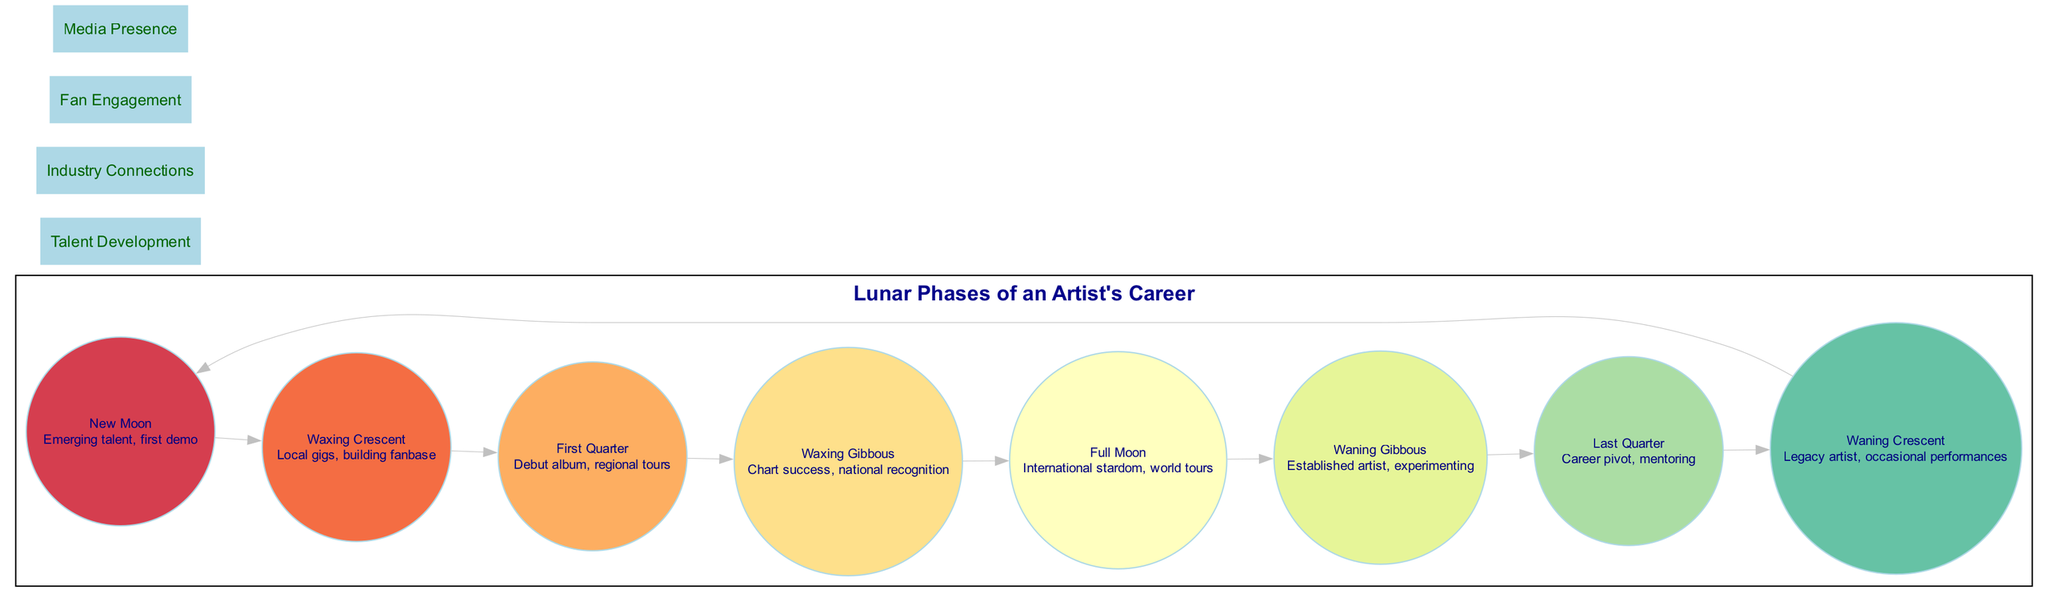What is the first phase of an artist's career development? The diagram lists the phases of an artist's career development in a circular order. The first phase is labeled as "New Moon."
Answer: New Moon What represents the phase after "First Quarter"? By examining the circular arrangement of the phases, "First Quarter" is directly connected to the next phase, which is "Waxing Gibbous."
Answer: Waxing Gibbous How many total phases are depicted in the diagram? The diagram has eight distinct phases labeled around the circular structure. Counting each phase provides the total number of phases.
Answer: Eight What is the description of the "Full Moon" phase? Each phase is accompanied by a description. In this case, "Full Moon" is described as "International stardom, world tours."
Answer: International stardom, world tours In what phase is an artist experimenting? The phase that signifies an established artist trying new things is labeled "Waning Gibbous." By scanning through the diagram, this can be confirmed.
Answer: Waning Gibbous What phase corresponds to building a fanbase? The chart states that the "Waxing Crescent" phase focuses on local gigs and the development of a fanbase. Therefore, this can be derived directly.
Answer: Waxing Crescent By examining the label "Media Presence," which phase is most likely connected with it? Considering that "Media Presence" typically comes into play as an artist gains more visibility, it relates closely to "Waxing Gibbous" when an artist is achieving chart success.
Answer: Waxing Gibbous What phase involves mentoring? Among the phases, "Last Quarter" specifically mentions a "career pivot" and includes mentoring, making it the relevant phase.
Answer: Last Quarter 